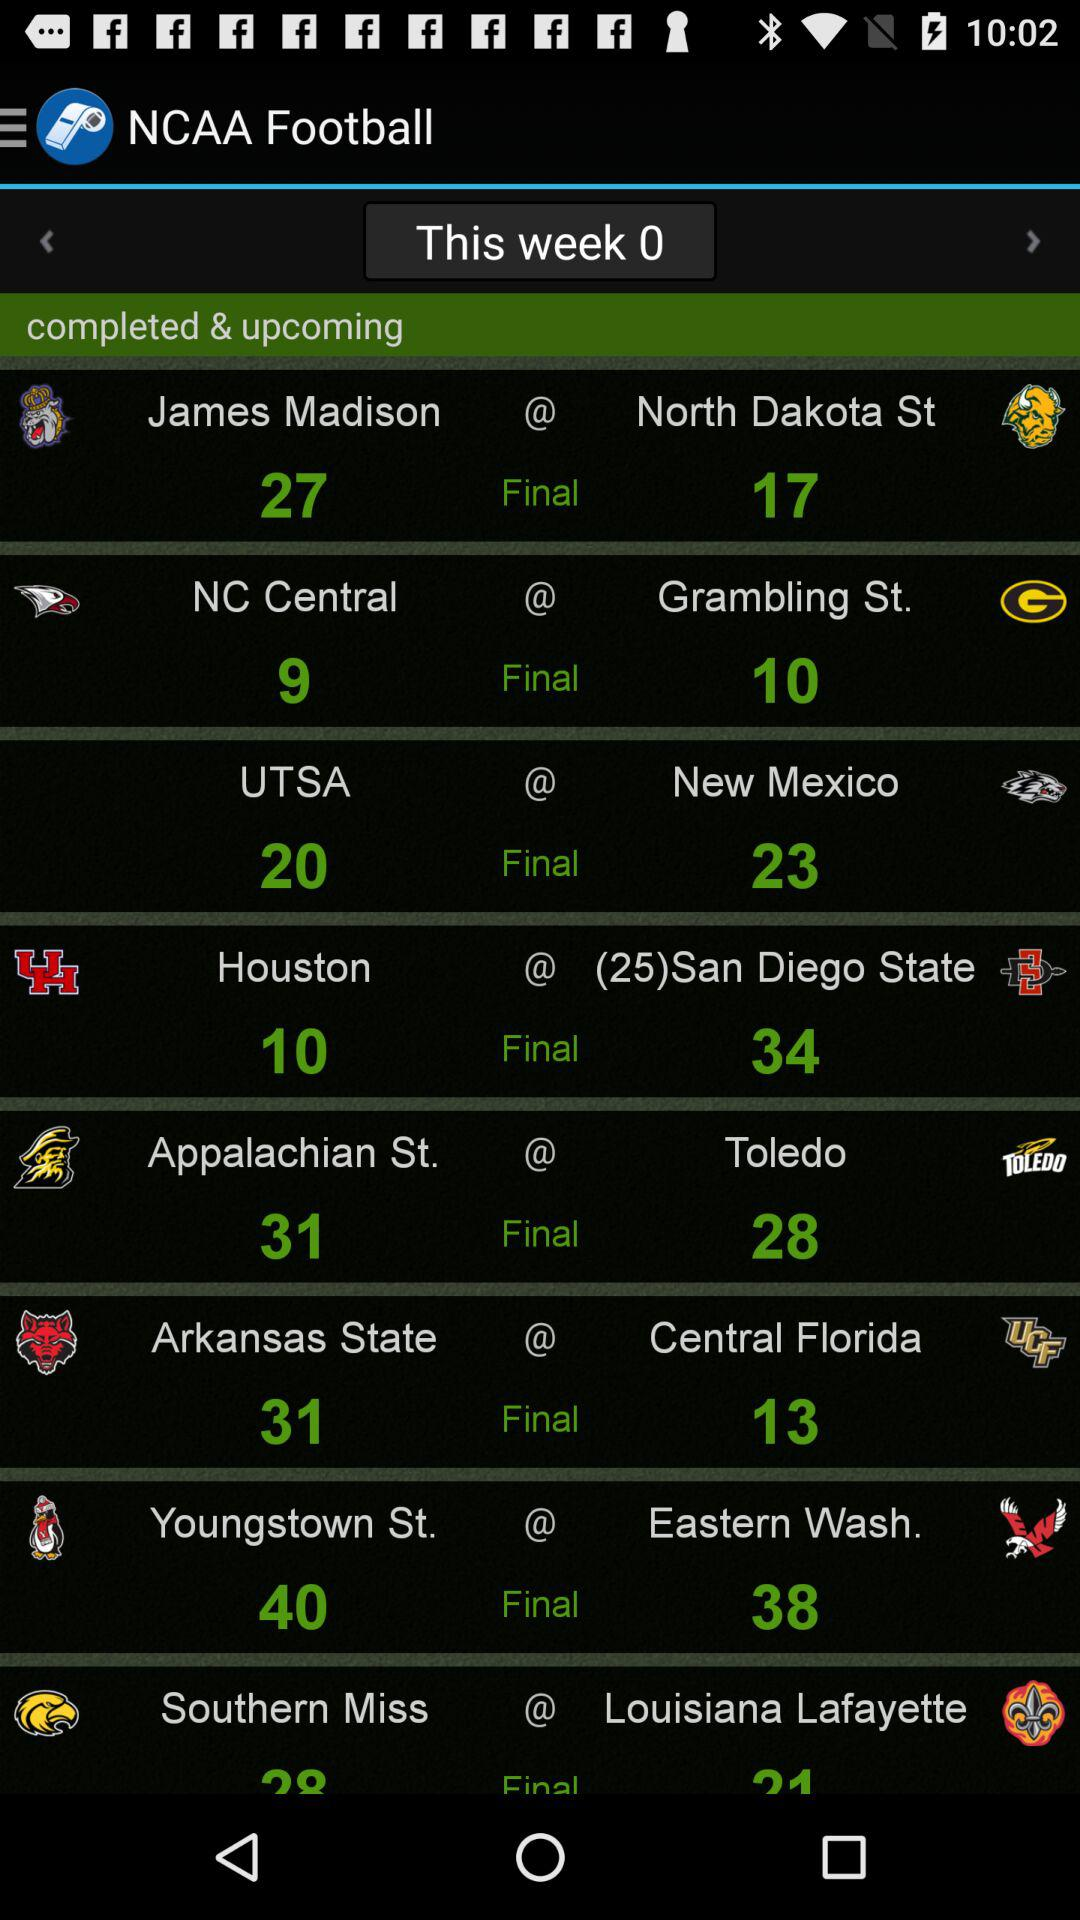Which team's final score is twenty? The team is "UTSA". 